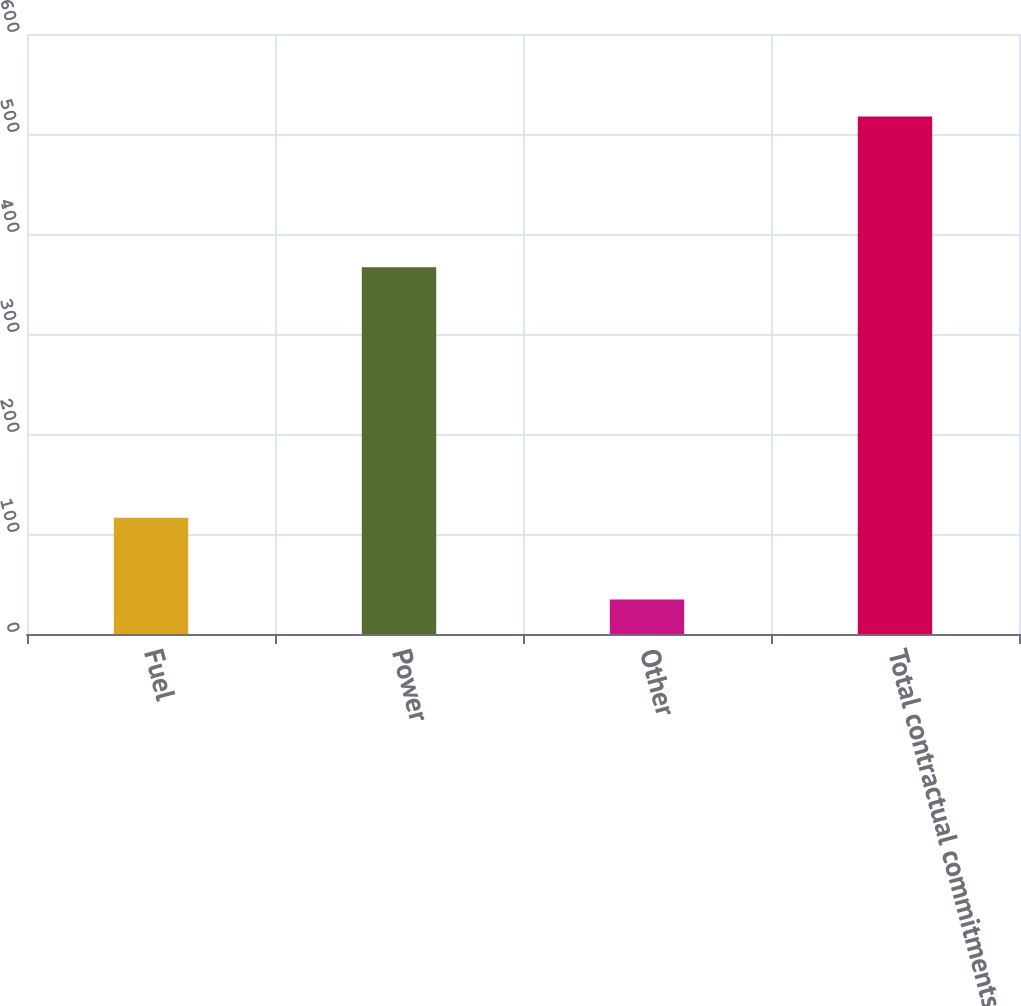Convert chart to OTSL. <chart><loc_0><loc_0><loc_500><loc_500><bar_chart><fcel>Fuel<fcel>Power<fcel>Other<fcel>Total contractual commitments<nl><fcel>116.2<fcel>366.8<fcel>34.4<fcel>517.4<nl></chart> 